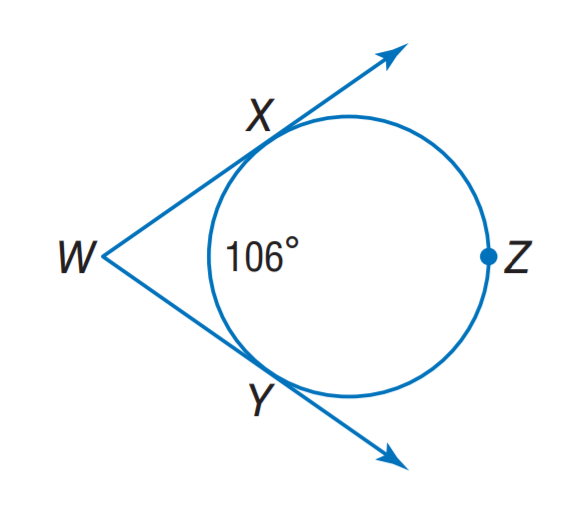Question: Find m \angle W.
Choices:
A. 74
B. 76
C. 104
D. 106
Answer with the letter. Answer: A 